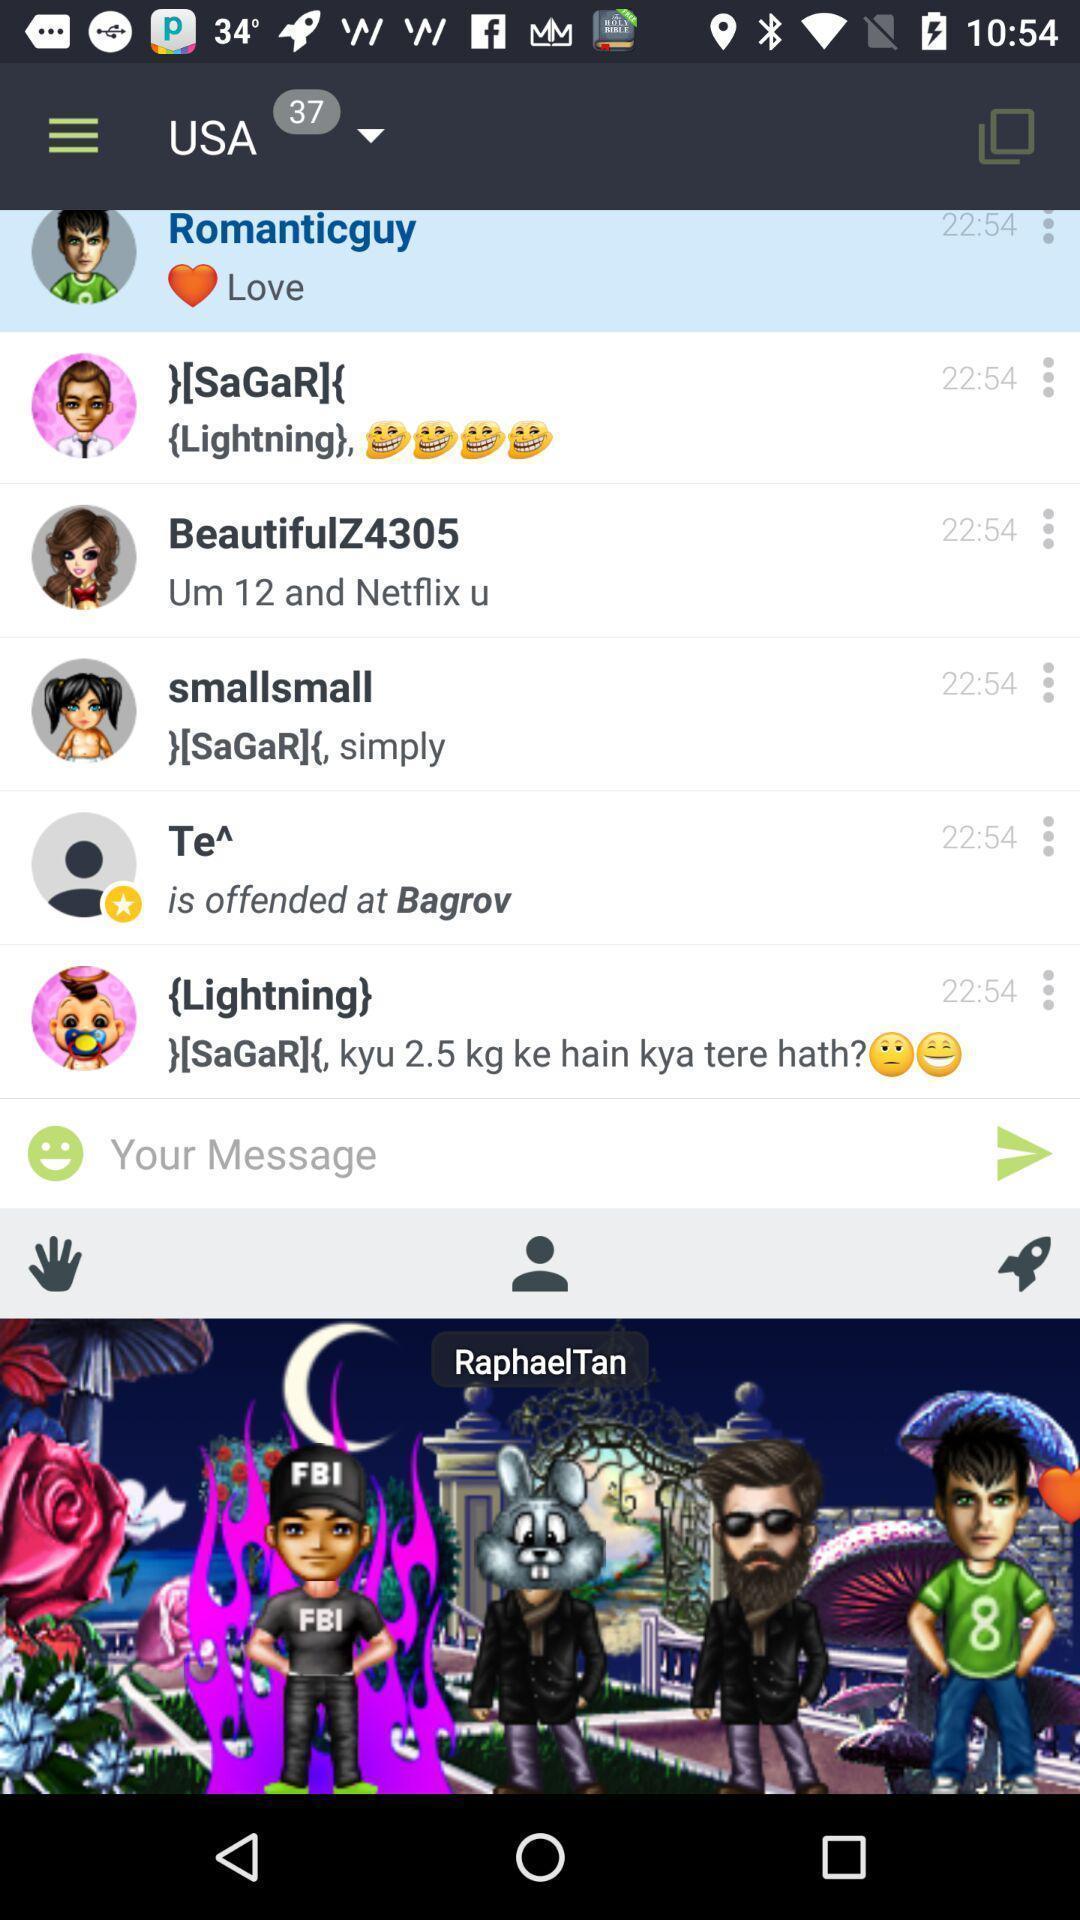Summarize the main components in this picture. Page showing the chat listings in social app. 